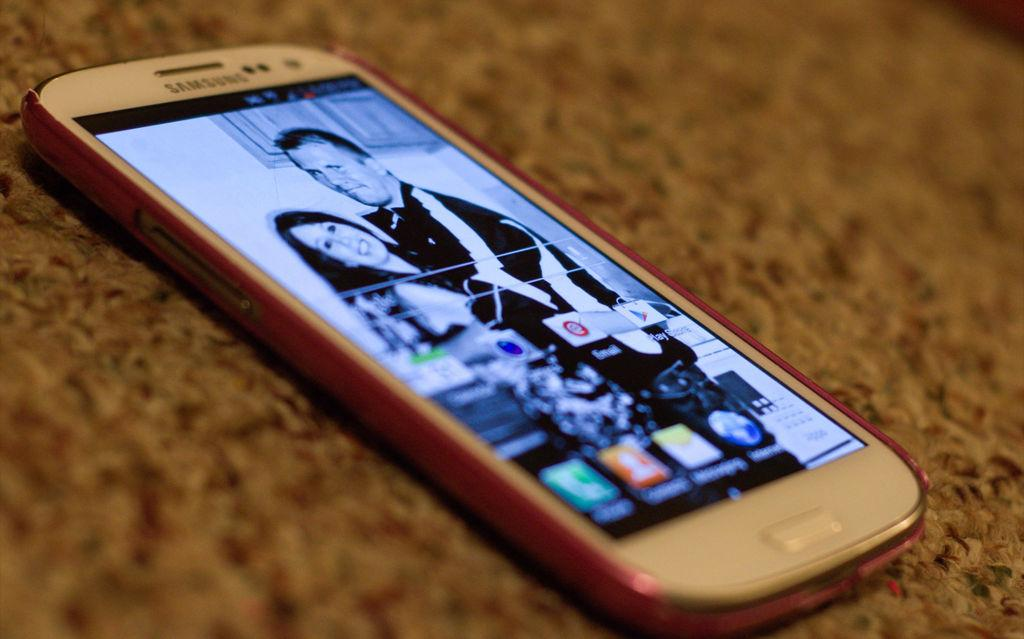Provide a one-sentence caption for the provided image. A phone on a home screen with the play store app appearing in the first row. 